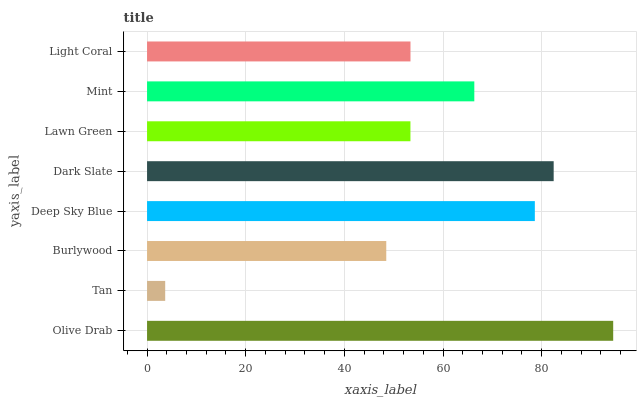Is Tan the minimum?
Answer yes or no. Yes. Is Olive Drab the maximum?
Answer yes or no. Yes. Is Burlywood the minimum?
Answer yes or no. No. Is Burlywood the maximum?
Answer yes or no. No. Is Burlywood greater than Tan?
Answer yes or no. Yes. Is Tan less than Burlywood?
Answer yes or no. Yes. Is Tan greater than Burlywood?
Answer yes or no. No. Is Burlywood less than Tan?
Answer yes or no. No. Is Mint the high median?
Answer yes or no. Yes. Is Light Coral the low median?
Answer yes or no. Yes. Is Tan the high median?
Answer yes or no. No. Is Dark Slate the low median?
Answer yes or no. No. 